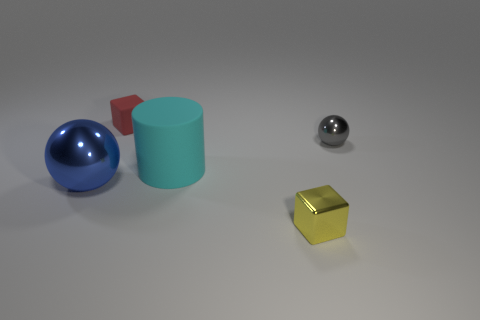Add 4 blue things. How many objects exist? 9 Subtract all cylinders. How many objects are left? 4 Add 5 red objects. How many red objects are left? 6 Add 5 tiny red matte things. How many tiny red matte things exist? 6 Subtract 0 yellow balls. How many objects are left? 5 Subtract all large red blocks. Subtract all spheres. How many objects are left? 3 